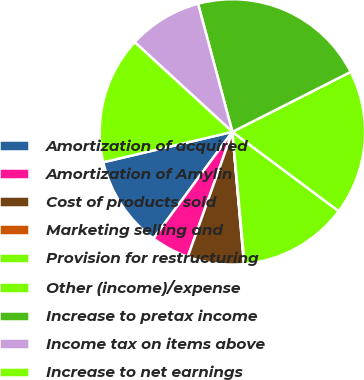Convert chart. <chart><loc_0><loc_0><loc_500><loc_500><pie_chart><fcel>Amortization of acquired<fcel>Amortization of Amylin<fcel>Cost of products sold<fcel>Marketing selling and<fcel>Provision for restructuring<fcel>Other (income)/expense<fcel>Increase to pretax income<fcel>Income tax on items above<fcel>Increase to net earnings<nl><fcel>11.18%<fcel>4.69%<fcel>6.85%<fcel>0.07%<fcel>13.34%<fcel>17.66%<fcel>21.7%<fcel>9.01%<fcel>15.5%<nl></chart> 